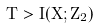Convert formula to latex. <formula><loc_0><loc_0><loc_500><loc_500>T > I ( X ; Z _ { 2 } )</formula> 